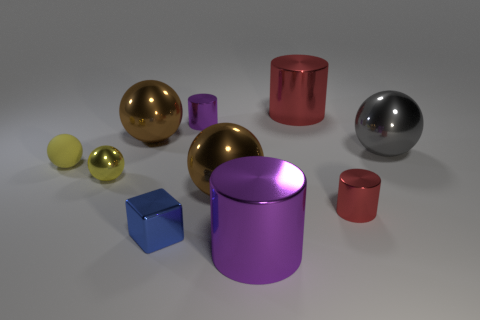There is a block that is made of the same material as the gray ball; what color is it?
Provide a short and direct response. Blue. There is a small cylinder that is behind the metal sphere that is left of the large brown ball to the left of the tiny blue metallic thing; what is its color?
Offer a very short reply. Purple. What number of cubes are either yellow rubber objects or gray metallic things?
Give a very brief answer. 0. What is the material of the other small sphere that is the same color as the tiny metallic sphere?
Keep it short and to the point. Rubber. There is a block; is it the same color as the large ball in front of the yellow metallic thing?
Provide a short and direct response. No. The shiny cube is what color?
Provide a short and direct response. Blue. What number of things are either tiny blocks or big spheres?
Provide a succinct answer. 4. There is a red cylinder that is the same size as the yellow shiny sphere; what is it made of?
Ensure brevity in your answer.  Metal. What size is the red metal object that is behind the big gray shiny object?
Make the answer very short. Large. What number of things are either shiny objects in front of the tiny yellow metal object or big brown shiny balls on the right side of the tiny block?
Offer a very short reply. 4. 